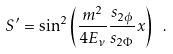Convert formula to latex. <formula><loc_0><loc_0><loc_500><loc_500>S ^ { \prime } = \sin ^ { 2 } \left ( \frac { m ^ { 2 } } { 4 E _ { \nu } } \frac { s _ { 2 \phi } } { s _ { 2 \Phi } } x \right ) \ .</formula> 